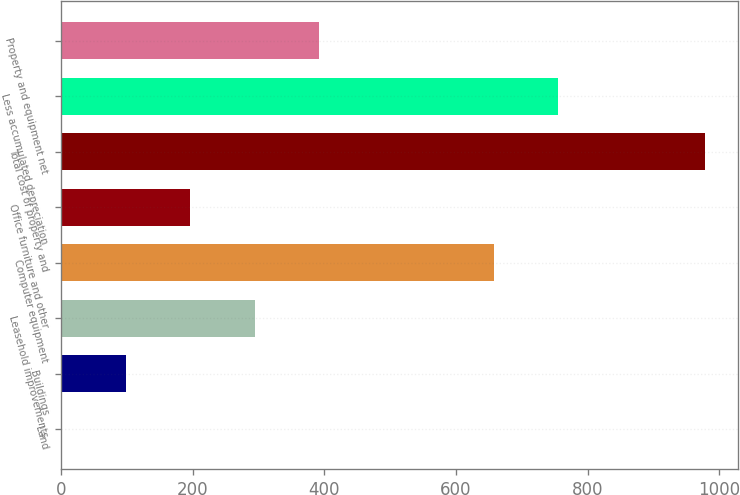Convert chart to OTSL. <chart><loc_0><loc_0><loc_500><loc_500><bar_chart><fcel>Land<fcel>Buildings<fcel>Leasehold improvements<fcel>Computer equipment<fcel>Office furniture and other<fcel>Total cost of property and<fcel>Less accumulated depreciation<fcel>Property and equipment net<nl><fcel>1<fcel>98.8<fcel>294.4<fcel>658<fcel>196.6<fcel>979<fcel>755.8<fcel>392.2<nl></chart> 